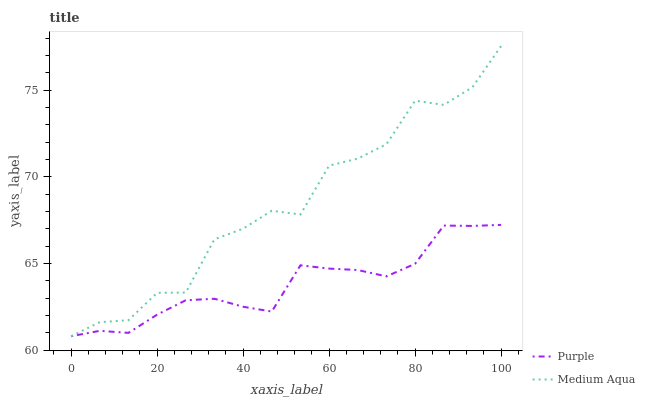Does Purple have the minimum area under the curve?
Answer yes or no. Yes. Does Medium Aqua have the maximum area under the curve?
Answer yes or no. Yes. Does Medium Aqua have the minimum area under the curve?
Answer yes or no. No. Is Purple the smoothest?
Answer yes or no. Yes. Is Medium Aqua the roughest?
Answer yes or no. Yes. Is Medium Aqua the smoothest?
Answer yes or no. No. Does Medium Aqua have the lowest value?
Answer yes or no. Yes. Does Medium Aqua have the highest value?
Answer yes or no. Yes. Does Medium Aqua intersect Purple?
Answer yes or no. Yes. Is Medium Aqua less than Purple?
Answer yes or no. No. Is Medium Aqua greater than Purple?
Answer yes or no. No. 